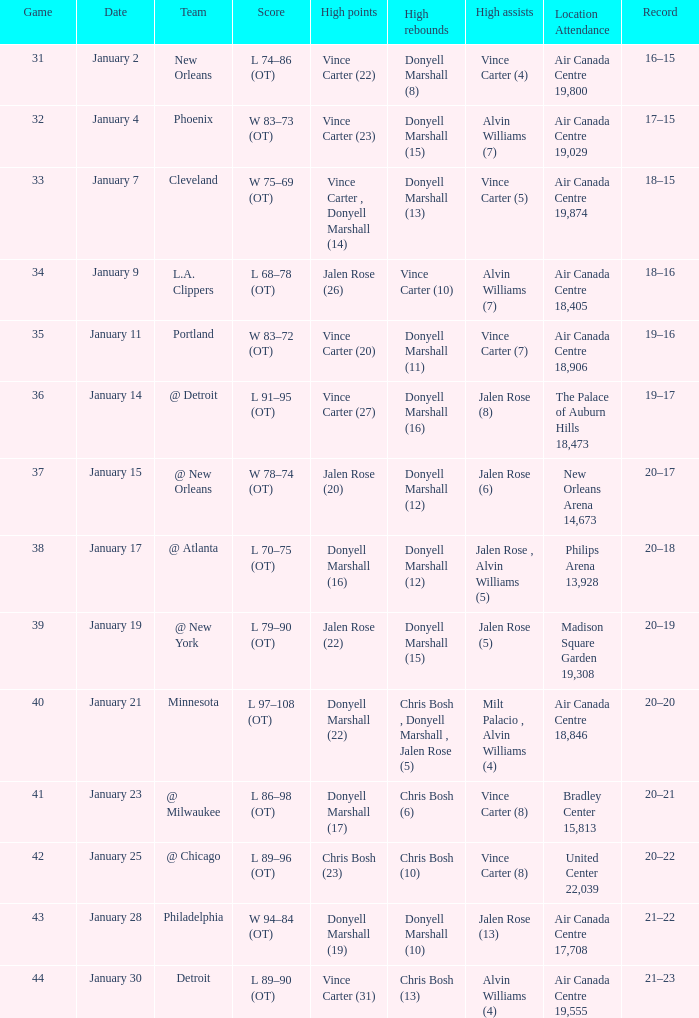What is the site and presence with a history of 21-22? Air Canada Centre 17,708. Help me parse the entirety of this table. {'header': ['Game', 'Date', 'Team', 'Score', 'High points', 'High rebounds', 'High assists', 'Location Attendance', 'Record'], 'rows': [['31', 'January 2', 'New Orleans', 'L 74–86 (OT)', 'Vince Carter (22)', 'Donyell Marshall (8)', 'Vince Carter (4)', 'Air Canada Centre 19,800', '16–15'], ['32', 'January 4', 'Phoenix', 'W 83–73 (OT)', 'Vince Carter (23)', 'Donyell Marshall (15)', 'Alvin Williams (7)', 'Air Canada Centre 19,029', '17–15'], ['33', 'January 7', 'Cleveland', 'W 75–69 (OT)', 'Vince Carter , Donyell Marshall (14)', 'Donyell Marshall (13)', 'Vince Carter (5)', 'Air Canada Centre 19,874', '18–15'], ['34', 'January 9', 'L.A. Clippers', 'L 68–78 (OT)', 'Jalen Rose (26)', 'Vince Carter (10)', 'Alvin Williams (7)', 'Air Canada Centre 18,405', '18–16'], ['35', 'January 11', 'Portland', 'W 83–72 (OT)', 'Vince Carter (20)', 'Donyell Marshall (11)', 'Vince Carter (7)', 'Air Canada Centre 18,906', '19–16'], ['36', 'January 14', '@ Detroit', 'L 91–95 (OT)', 'Vince Carter (27)', 'Donyell Marshall (16)', 'Jalen Rose (8)', 'The Palace of Auburn Hills 18,473', '19–17'], ['37', 'January 15', '@ New Orleans', 'W 78–74 (OT)', 'Jalen Rose (20)', 'Donyell Marshall (12)', 'Jalen Rose (6)', 'New Orleans Arena 14,673', '20–17'], ['38', 'January 17', '@ Atlanta', 'L 70–75 (OT)', 'Donyell Marshall (16)', 'Donyell Marshall (12)', 'Jalen Rose , Alvin Williams (5)', 'Philips Arena 13,928', '20–18'], ['39', 'January 19', '@ New York', 'L 79–90 (OT)', 'Jalen Rose (22)', 'Donyell Marshall (15)', 'Jalen Rose (5)', 'Madison Square Garden 19,308', '20–19'], ['40', 'January 21', 'Minnesota', 'L 97–108 (OT)', 'Donyell Marshall (22)', 'Chris Bosh , Donyell Marshall , Jalen Rose (5)', 'Milt Palacio , Alvin Williams (4)', 'Air Canada Centre 18,846', '20–20'], ['41', 'January 23', '@ Milwaukee', 'L 86–98 (OT)', 'Donyell Marshall (17)', 'Chris Bosh (6)', 'Vince Carter (8)', 'Bradley Center 15,813', '20–21'], ['42', 'January 25', '@ Chicago', 'L 89–96 (OT)', 'Chris Bosh (23)', 'Chris Bosh (10)', 'Vince Carter (8)', 'United Center 22,039', '20–22'], ['43', 'January 28', 'Philadelphia', 'W 94–84 (OT)', 'Donyell Marshall (19)', 'Donyell Marshall (10)', 'Jalen Rose (13)', 'Air Canada Centre 17,708', '21–22'], ['44', 'January 30', 'Detroit', 'L 89–90 (OT)', 'Vince Carter (31)', 'Chris Bosh (13)', 'Alvin Williams (4)', 'Air Canada Centre 19,555', '21–23']]} 